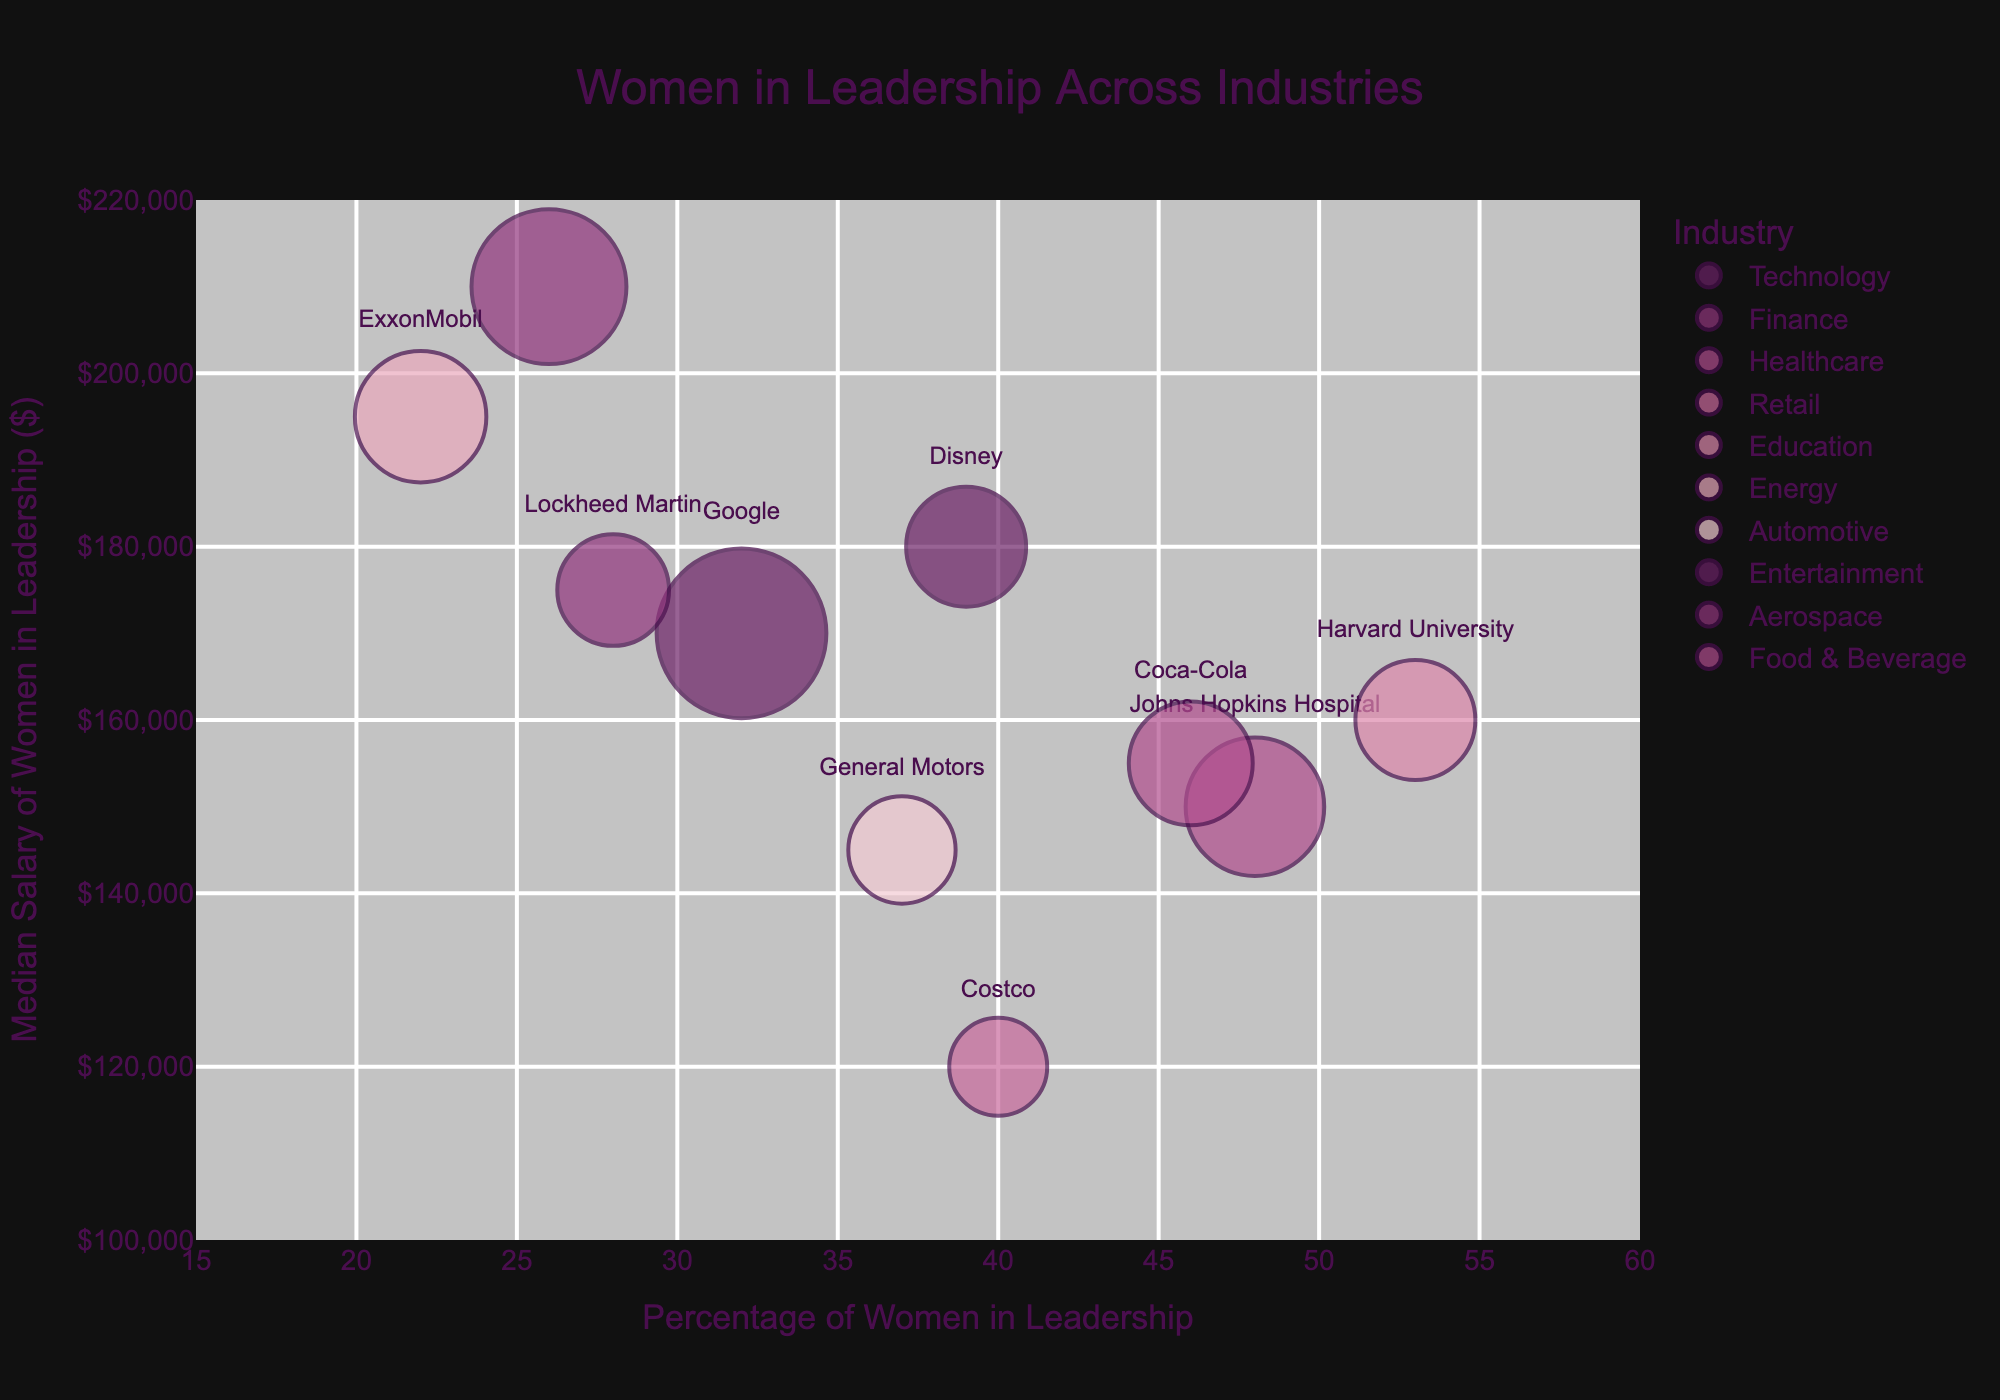What is the title of the chart? The title is usually located at the top of the chart. In this case, the title is "Women in Leadership Across Industries".
Answer: Women in Leadership Across Industries Which industry has the highest percentage of women in leadership roles? Look at the x-axis, which represents the percentage of women in leadership, and find the data point farthest to the right. The industry for that point is labeled as Education with a percentage of 53% at Harvard University.
Answer: Education (Harvard University) What is the median salary of women in leadership in the Technology industry? Look for the bubble labeled "Google" on the y-axis, which shows the median salary of women in leadership. The y-coordinate for the Technology industry (Google) is $170,000.
Answer: $170,000 How many total leadership roles are there in the Healthcare industry? Check the size of the bubble labeled "Johns Hopkins Hospital" in the Healthcare industry. The size of the bubble corresponds to the number of total leadership roles, which is 200.
Answer: 200 Which industry has the highest median salary for women in leadership roles, and what is that salary? Look at the y-axis and find the highest value point. The highest median salary is in the Finance industry (Goldman Sachs) with a salary of $210,000.
Answer: Finance (Goldman Sachs), $210,000 Compare the percentage of women in leadership between the Automotive and Aerospace industries. Which has a higher percentage and by how much? Identify the bubbles labeled "General Motors" and "Lockheed Martin". The x-coordinate for General Motors (Automotive) is 37%, and for Lockheed Martin (Aerospace) is 28%. The difference is 37% - 28% = 9%.
Answer: Automotive (General Motors), 9% Which company has the lowest median salary of women in leadership roles? Look for the point lowest on the y-axis. The company represented by that point is Costco (Retail) with a salary of $120,000.
Answer: Costco Compare the median salaries of women in leadership between the Energy and Entertainment industries. Which one is higher and by how much? Locate "ExxonMobil" (Energy) and "Disney" (Entertainment) on the y-axis. The salary for ExxonMobil is $195,000 and for Disney is $180,000. The difference is $195,000 - $180,000 = $15,000.
Answer: Energy (ExxonMobil), $15,000 What is the total number of leadership roles across companies with more than 40% women in leadership roles? Sum the total leadership roles for companies with greater than 40% women in leadership: Johns Hopkins Hospital (200), Costco (100), Harvard University (150), and Coca-Cola (160). 200 + 100 + 150 + 160 = 610 roles.
Answer: 610 Which company is represented by the largest bubble and why? The size of the bubble represents the total number of leadership roles. The largest bubble corresponds to Google (Technology) with 300 leadership roles.
Answer: Google 